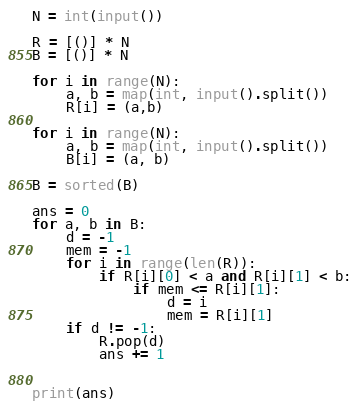<code> <loc_0><loc_0><loc_500><loc_500><_Python_>N = int(input())

R = [()] * N
B = [()] * N

for i in range(N):
    a, b = map(int, input().split())
    R[i] = (a,b)

for i in range(N):
    a, b = map(int, input().split())
    B[i] = (a, b)

B = sorted(B)

ans = 0
for a, b in B:
    d = -1
    mem = -1
    for i in range(len(R)):
        if R[i][0] < a and R[i][1] < b:
            if mem <= R[i][1]:
                d = i
                mem = R[i][1]
    if d != -1:
        R.pop(d)
        ans += 1


print(ans)



</code> 